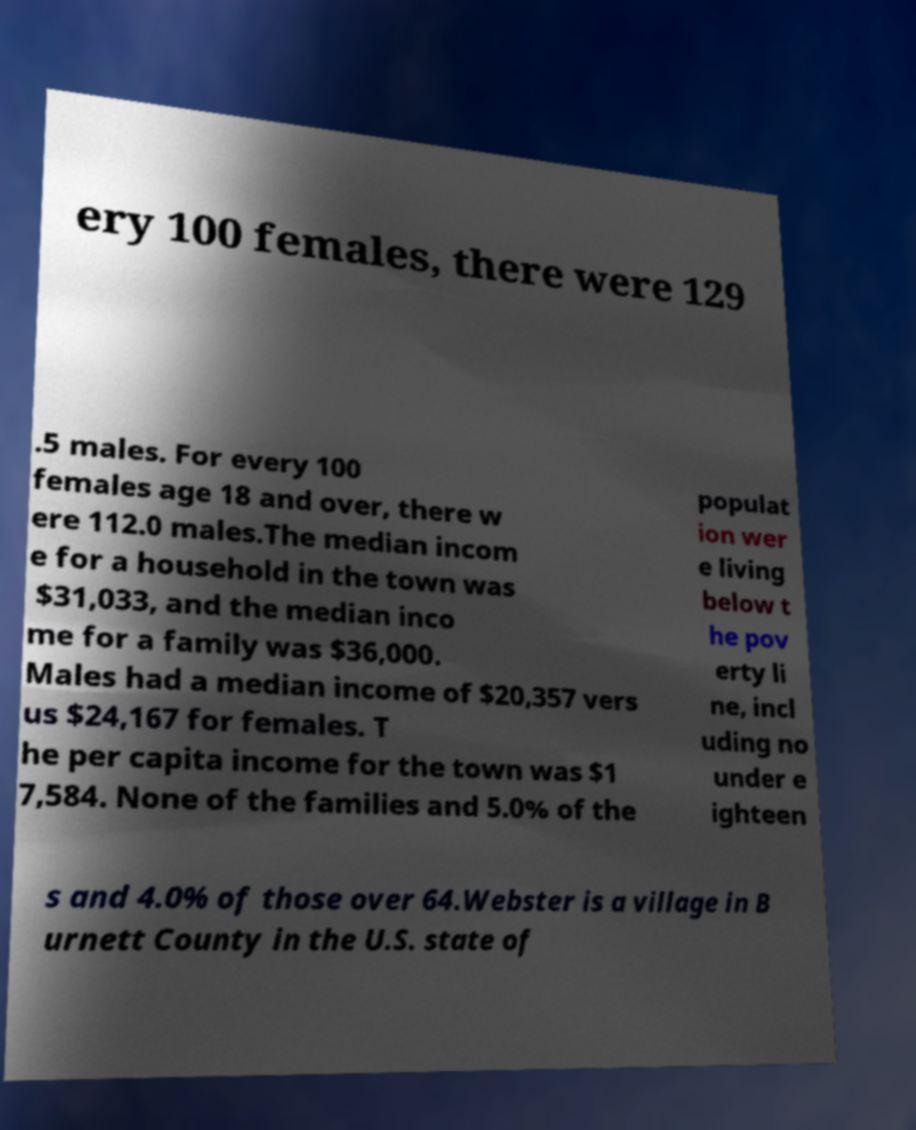Can you accurately transcribe the text from the provided image for me? ery 100 females, there were 129 .5 males. For every 100 females age 18 and over, there w ere 112.0 males.The median incom e for a household in the town was $31,033, and the median inco me for a family was $36,000. Males had a median income of $20,357 vers us $24,167 for females. T he per capita income for the town was $1 7,584. None of the families and 5.0% of the populat ion wer e living below t he pov erty li ne, incl uding no under e ighteen s and 4.0% of those over 64.Webster is a village in B urnett County in the U.S. state of 